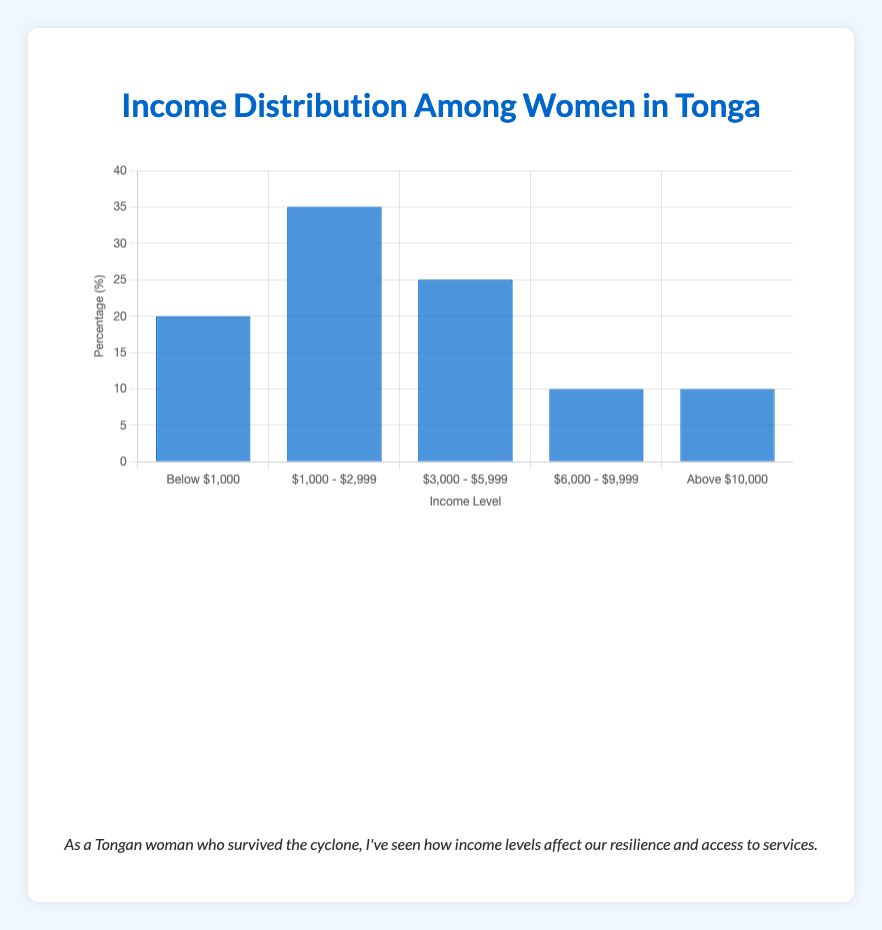Which income level has the highest percentage of women? By looking at the height of the bars, the "$1,000 - $2,999" income level has the tallest bar indicating the highest percentage.
Answer: $1,000 - $2,999 How many income levels have a percentage of 10%? There are two bars that reach the 10% mark, corresponding to the "$6,000 - $9,999" and "Above $10,000" income levels.
Answer: 2 What is the combined percentage of women earning below $3,000? Summing the percentages for "Below $1,000" (20%) and "$1,000 - $2,999" (35%) gives 20% + 35% = 55%.
Answer: 55% Which income range has the smallest percentage of women? By comparing the heights of the bars, the income ranges "$6,000 - $9,999" and "Above $10,000" both have the smallest bars, each at 10%.
Answer: $6,000 - $9,999, Above $10,000 What is the difference in percentage between women earning "$3,000 - $5,999" and those earning "Above $10,000"? Subtracting the percentage for "Above $10,000" (10%) from the percentage for "$3,000 - $5,999" (25%) gives 25% - 10% = 15%.
Answer: 15% What percentage of women earn $6,000 or more? Adding the percentages for "$6,000 - $9,999" (10%) and "Above $10,000" (10%) gives 10% + 10% = 20%.
Answer: 20% How does the percentage of women earning "Below $1,000" compare to those earning "$1,000 - $2,999"? By comparing the heights of the bars, the "Below $1,000" category (20%) is shorter than the "$1,000 - $2,999" category (35%).
Answer: Below $1,000 < $1,000 - $2,999 What is the average percentage of all income levels shown? Summing all the percentages (20% + 35% + 25% + 10% + 10%) gives 100%, then dividing by the number of levels (5) gives 100% / 5 = 20%.
Answer: 20% If you combine the percentage of women earning above $3,000, what is the total? Adding the percentages for "$3,000 - $5,999" (25%), "$6,000 - $9,999" (10%), and "Above $10,000" (10%) gives 25% + 10% + 10% = 45%.
Answer: 45% Which income category has a description related to subsistence farming and small-scale local trade? The description is mentioned for the "Below $1,000" income category.
Answer: Below $1,000 